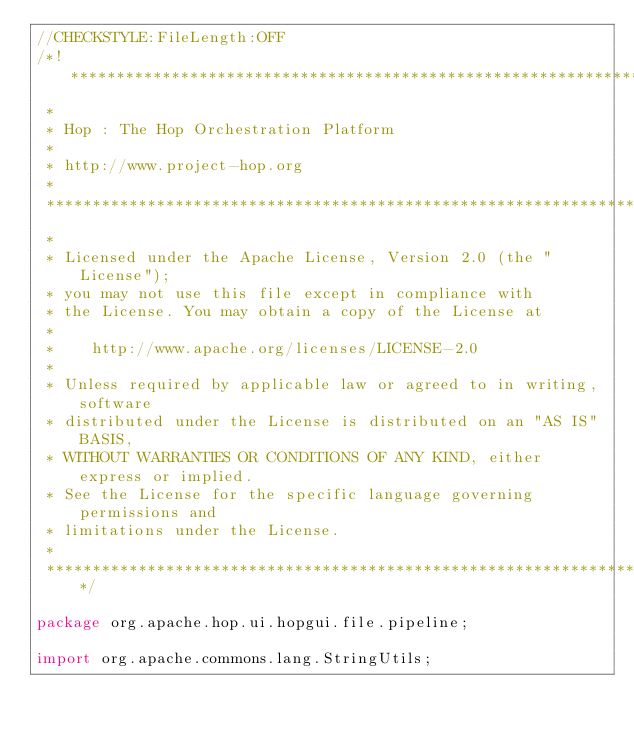Convert code to text. <code><loc_0><loc_0><loc_500><loc_500><_Java_>//CHECKSTYLE:FileLength:OFF
/*! ******************************************************************************
 *
 * Hop : The Hop Orchestration Platform
 *
 * http://www.project-hop.org
 *
 *******************************************************************************
 *
 * Licensed under the Apache License, Version 2.0 (the "License");
 * you may not use this file except in compliance with
 * the License. You may obtain a copy of the License at
 *
 *    http://www.apache.org/licenses/LICENSE-2.0
 *
 * Unless required by applicable law or agreed to in writing, software
 * distributed under the License is distributed on an "AS IS" BASIS,
 * WITHOUT WARRANTIES OR CONDITIONS OF ANY KIND, either express or implied.
 * See the License for the specific language governing permissions and
 * limitations under the License.
 *
 ******************************************************************************/

package org.apache.hop.ui.hopgui.file.pipeline;

import org.apache.commons.lang.StringUtils;</code> 